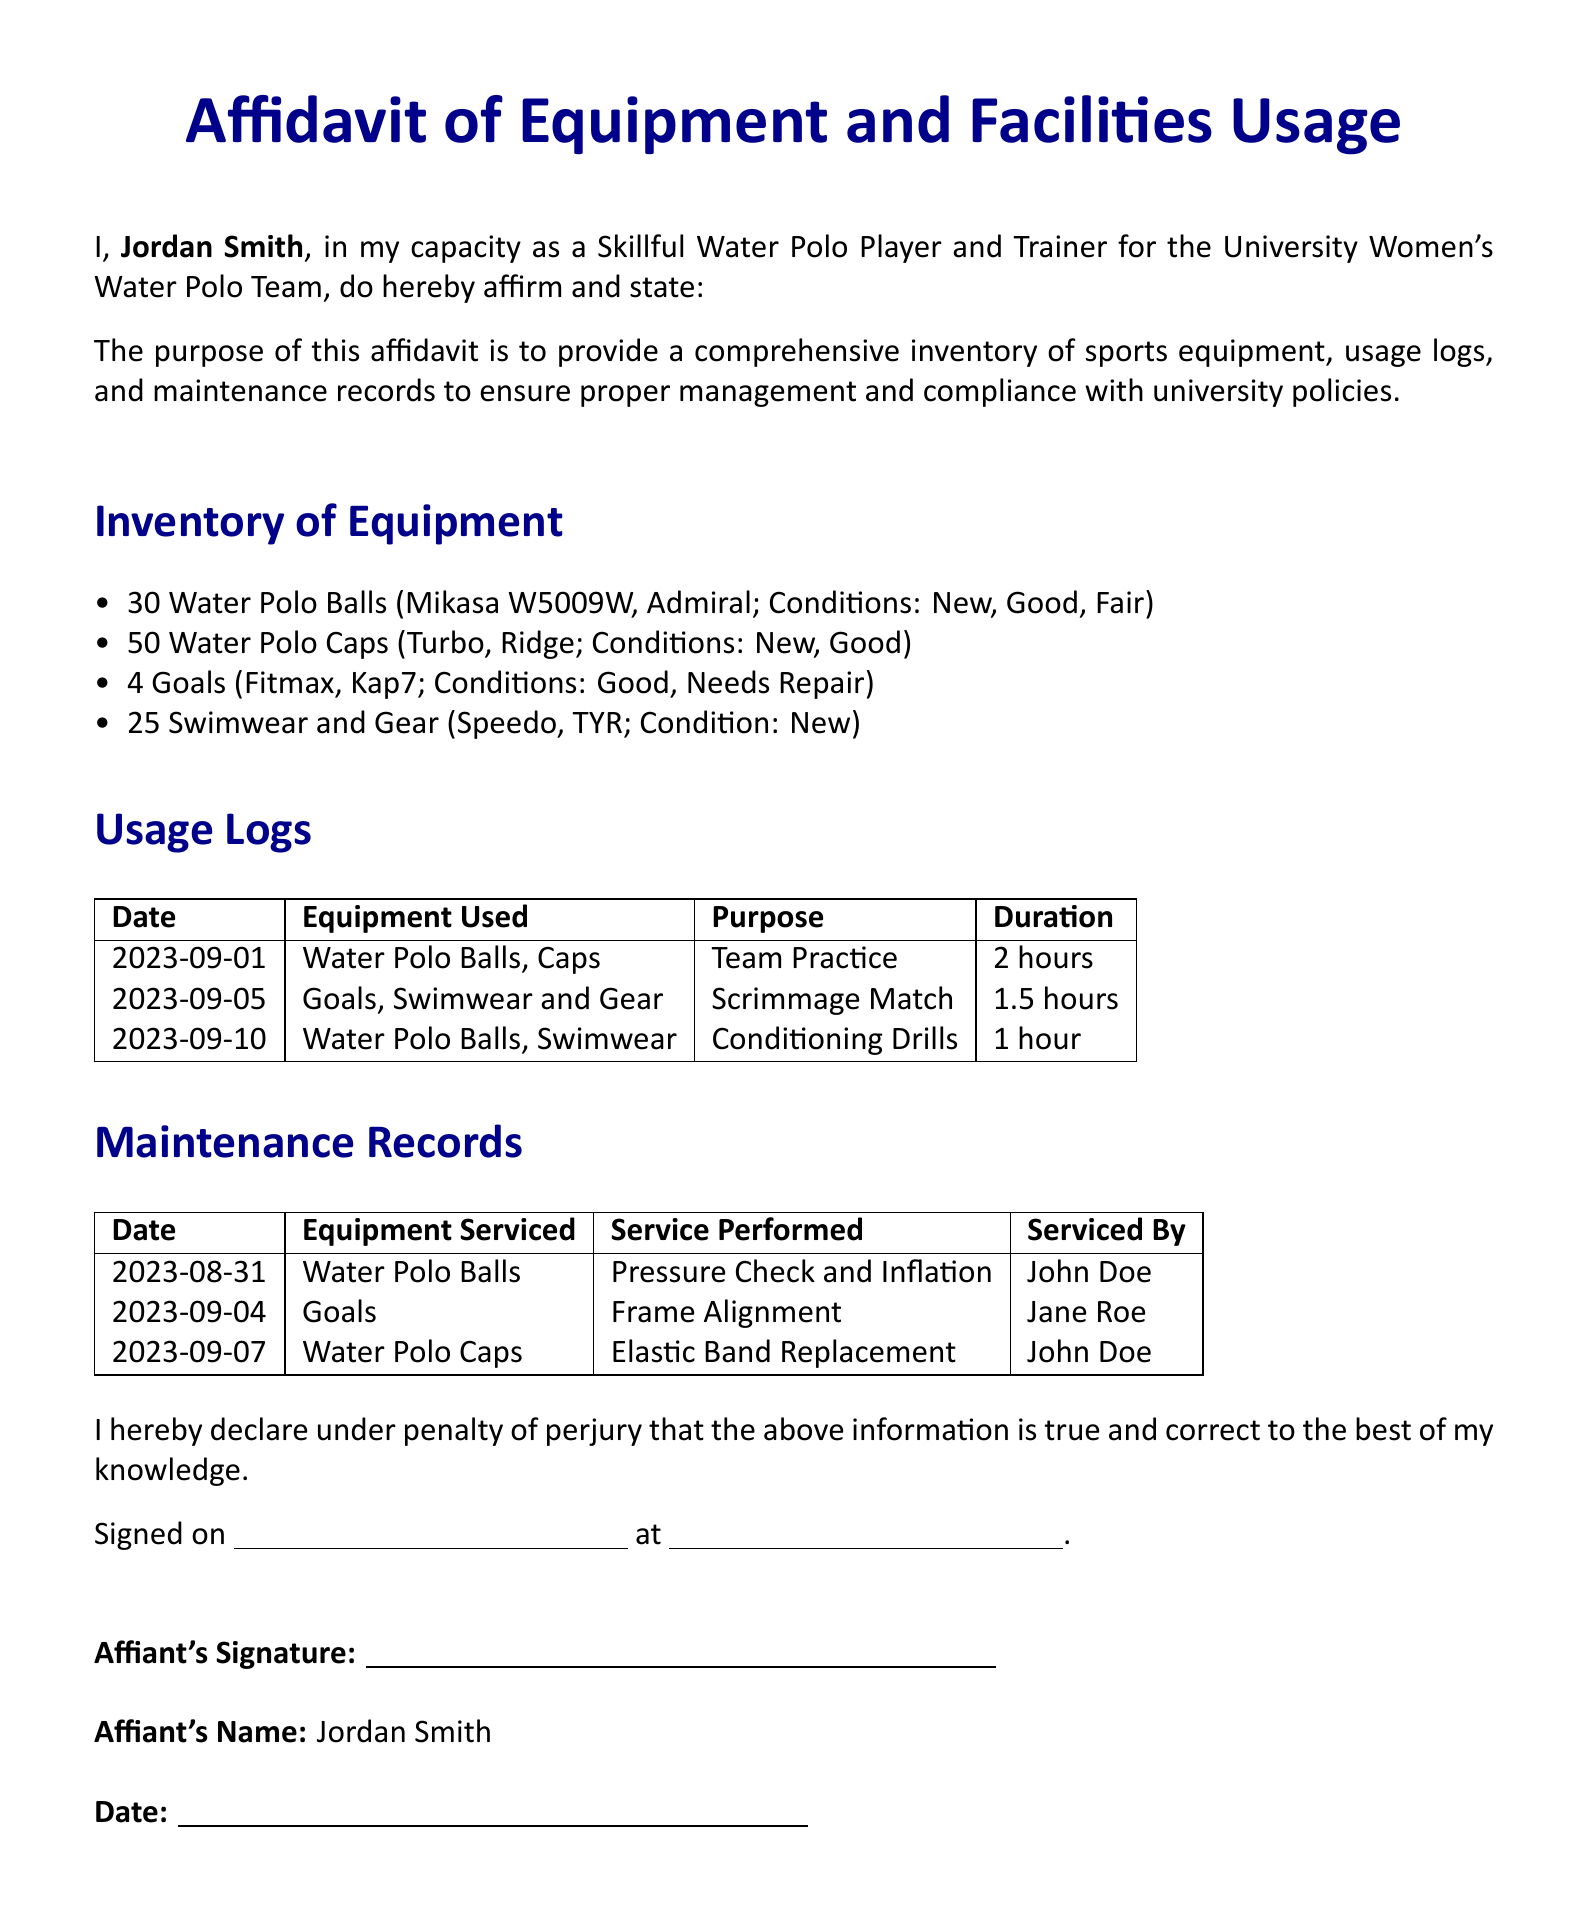What is the name of the affiant? The affiant's name is provided at the beginning of the document, which is Jordan Smith.
Answer: Jordan Smith How many water polo balls are listed in the inventory? The document lists a comprehensive inventory, and specifically states there are 30 water polo balls.
Answer: 30 What was the purpose of the equipment usage on September 5, 2023? The usage log for this date indicates the equipment was used for a Scrimmage Match.
Answer: Scrimmage Match Who performed the service on the goals on September 4, 2023? The maintenance records include the name of the person who serviced the goals, which is Jane Roe.
Answer: Jane Roe What condition is the swimwear in according to the inventory? The inventory specifically states that the swimwear is in New condition.
Answer: New What was the duration of team practice on September 1, 2023? The usage logs specify that the team practice lasted for 2 hours.
Answer: 2 hours How many goals are listed in the inventory? The inventory outlines that there are 4 goals included.
Answer: 4 What maintenance was performed on the water polo caps on September 7, 2023? The maintenance records document that elastic band replacement was performed on the caps.
Answer: Elastic Band Replacement Under what penalty does the affiant declare the information is true? The affiant states the information is declared under penalty of perjury.
Answer: Perjury 